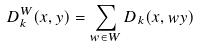Convert formula to latex. <formula><loc_0><loc_0><loc_500><loc_500>D _ { k } ^ { W } ( x , y ) = \sum _ { w \in W } D _ { k } ( x , w y )</formula> 